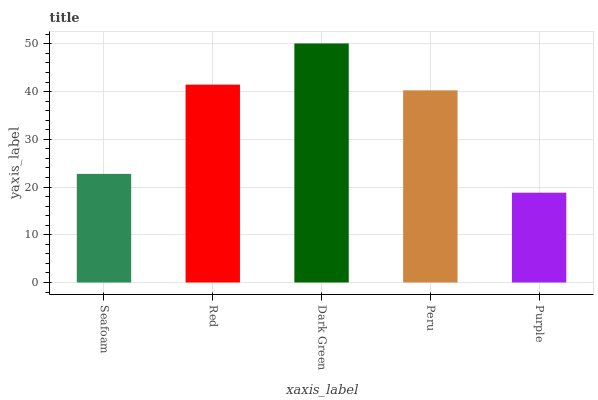Is Purple the minimum?
Answer yes or no. Yes. Is Dark Green the maximum?
Answer yes or no. Yes. Is Red the minimum?
Answer yes or no. No. Is Red the maximum?
Answer yes or no. No. Is Red greater than Seafoam?
Answer yes or no. Yes. Is Seafoam less than Red?
Answer yes or no. Yes. Is Seafoam greater than Red?
Answer yes or no. No. Is Red less than Seafoam?
Answer yes or no. No. Is Peru the high median?
Answer yes or no. Yes. Is Peru the low median?
Answer yes or no. Yes. Is Seafoam the high median?
Answer yes or no. No. Is Seafoam the low median?
Answer yes or no. No. 